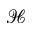<formula> <loc_0><loc_0><loc_500><loc_500>\mathcal { H }</formula> 